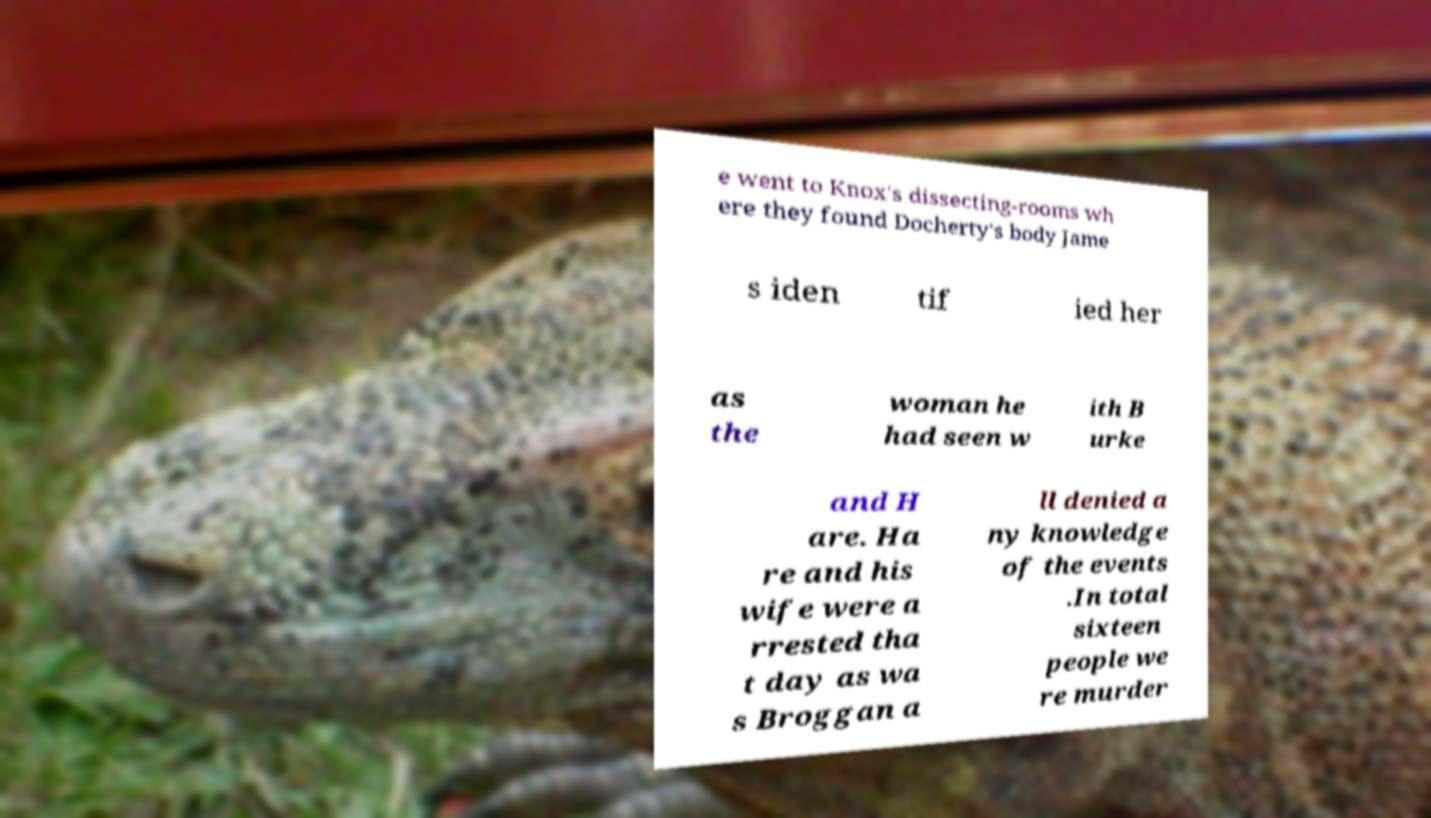There's text embedded in this image that I need extracted. Can you transcribe it verbatim? e went to Knox's dissecting-rooms wh ere they found Docherty's body Jame s iden tif ied her as the woman he had seen w ith B urke and H are. Ha re and his wife were a rrested tha t day as wa s Broggan a ll denied a ny knowledge of the events .In total sixteen people we re murder 